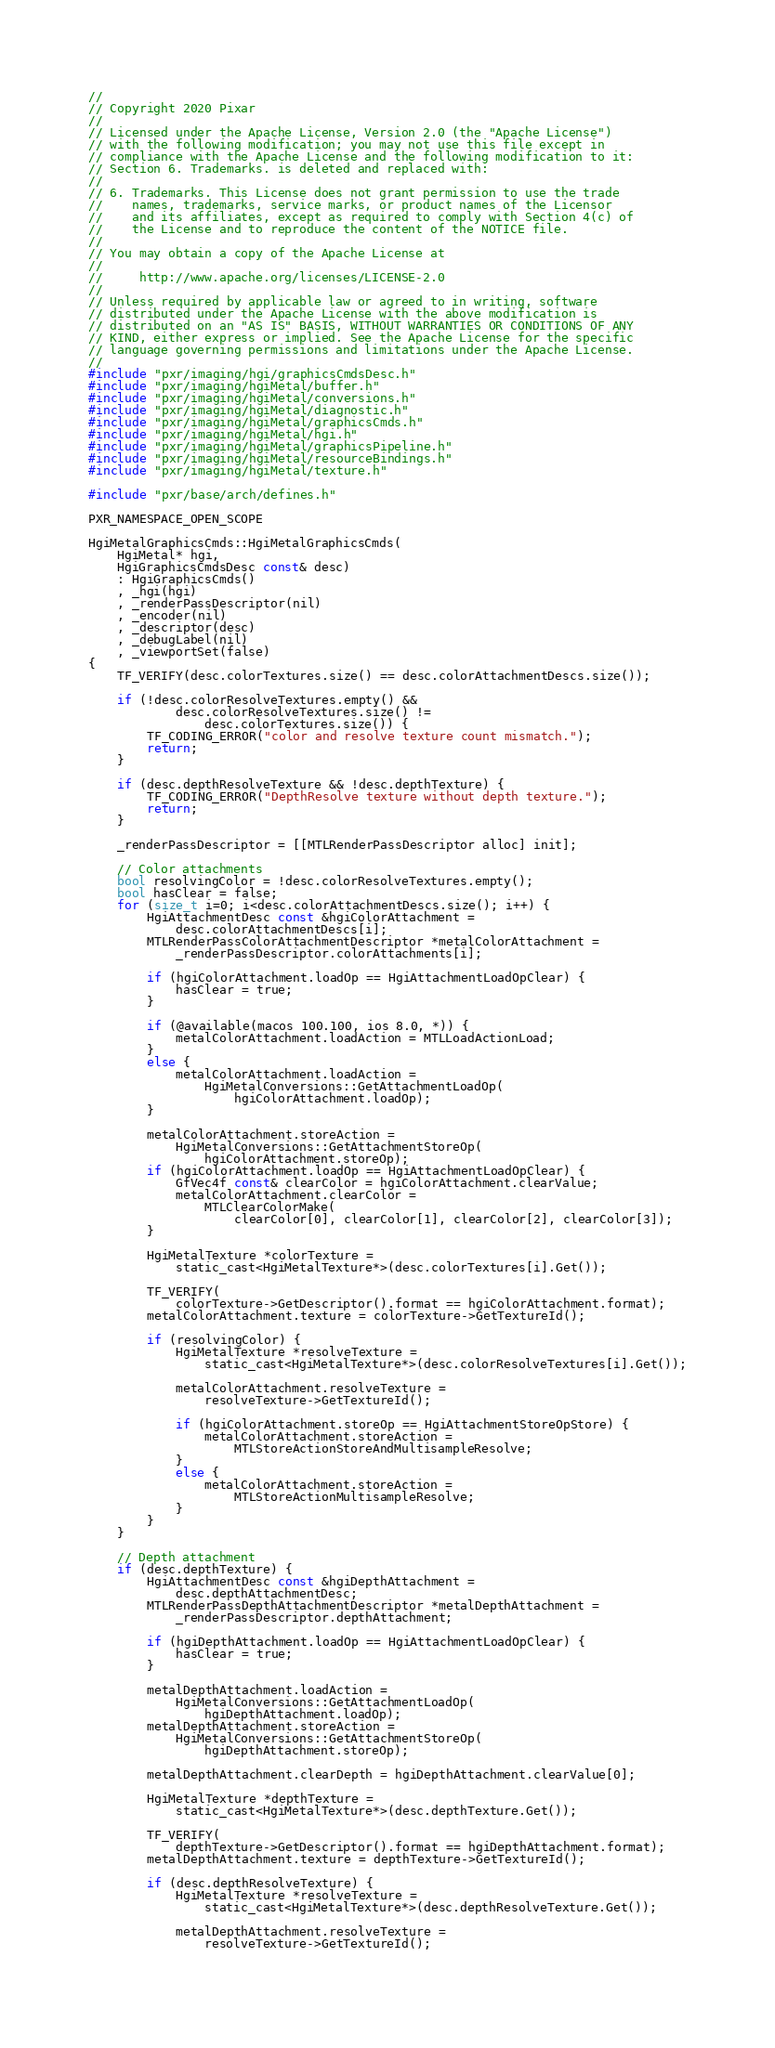Convert code to text. <code><loc_0><loc_0><loc_500><loc_500><_ObjectiveC_>//
// Copyright 2020 Pixar
//
// Licensed under the Apache License, Version 2.0 (the "Apache License")
// with the following modification; you may not use this file except in
// compliance with the Apache License and the following modification to it:
// Section 6. Trademarks. is deleted and replaced with:
//
// 6. Trademarks. This License does not grant permission to use the trade
//    names, trademarks, service marks, or product names of the Licensor
//    and its affiliates, except as required to comply with Section 4(c) of
//    the License and to reproduce the content of the NOTICE file.
//
// You may obtain a copy of the Apache License at
//
//     http://www.apache.org/licenses/LICENSE-2.0
//
// Unless required by applicable law or agreed to in writing, software
// distributed under the Apache License with the above modification is
// distributed on an "AS IS" BASIS, WITHOUT WARRANTIES OR CONDITIONS OF ANY
// KIND, either express or implied. See the Apache License for the specific
// language governing permissions and limitations under the Apache License.
//
#include "pxr/imaging/hgi/graphicsCmdsDesc.h"
#include "pxr/imaging/hgiMetal/buffer.h"
#include "pxr/imaging/hgiMetal/conversions.h"
#include "pxr/imaging/hgiMetal/diagnostic.h"
#include "pxr/imaging/hgiMetal/graphicsCmds.h"
#include "pxr/imaging/hgiMetal/hgi.h"
#include "pxr/imaging/hgiMetal/graphicsPipeline.h"
#include "pxr/imaging/hgiMetal/resourceBindings.h"
#include "pxr/imaging/hgiMetal/texture.h"

#include "pxr/base/arch/defines.h"

PXR_NAMESPACE_OPEN_SCOPE

HgiMetalGraphicsCmds::HgiMetalGraphicsCmds(
    HgiMetal* hgi,
    HgiGraphicsCmdsDesc const& desc)
    : HgiGraphicsCmds()
    , _hgi(hgi)
    , _renderPassDescriptor(nil)
    , _encoder(nil)
    , _descriptor(desc)
    , _debugLabel(nil)
    , _viewportSet(false)
{
    TF_VERIFY(desc.colorTextures.size() == desc.colorAttachmentDescs.size());
    
    if (!desc.colorResolveTextures.empty() &&
            desc.colorResolveTextures.size() !=
                desc.colorTextures.size()) {
        TF_CODING_ERROR("color and resolve texture count mismatch.");
        return;
    }

    if (desc.depthResolveTexture && !desc.depthTexture) {
        TF_CODING_ERROR("DepthResolve texture without depth texture.");
        return;
    }

    _renderPassDescriptor = [[MTLRenderPassDescriptor alloc] init];

    // Color attachments
    bool resolvingColor = !desc.colorResolveTextures.empty();
    bool hasClear = false;
    for (size_t i=0; i<desc.colorAttachmentDescs.size(); i++) {
        HgiAttachmentDesc const &hgiColorAttachment =
            desc.colorAttachmentDescs[i];
        MTLRenderPassColorAttachmentDescriptor *metalColorAttachment =
            _renderPassDescriptor.colorAttachments[i];

        if (hgiColorAttachment.loadOp == HgiAttachmentLoadOpClear) {
            hasClear = true;
        }
        
        if (@available(macos 100.100, ios 8.0, *)) {
            metalColorAttachment.loadAction = MTLLoadActionLoad;
        }
        else {
            metalColorAttachment.loadAction =
                HgiMetalConversions::GetAttachmentLoadOp(
                    hgiColorAttachment.loadOp);
        }

        metalColorAttachment.storeAction =
            HgiMetalConversions::GetAttachmentStoreOp(
                hgiColorAttachment.storeOp);
        if (hgiColorAttachment.loadOp == HgiAttachmentLoadOpClear) {
            GfVec4f const& clearColor = hgiColorAttachment.clearValue;
            metalColorAttachment.clearColor =
                MTLClearColorMake(
                    clearColor[0], clearColor[1], clearColor[2], clearColor[3]);
        }
        
        HgiMetalTexture *colorTexture =
            static_cast<HgiMetalTexture*>(desc.colorTextures[i].Get());

        TF_VERIFY(
            colorTexture->GetDescriptor().format == hgiColorAttachment.format);
        metalColorAttachment.texture = colorTexture->GetTextureId();
        
        if (resolvingColor) {
            HgiMetalTexture *resolveTexture =
                static_cast<HgiMetalTexture*>(desc.colorResolveTextures[i].Get());

            metalColorAttachment.resolveTexture =
                resolveTexture->GetTextureId();

            if (hgiColorAttachment.storeOp == HgiAttachmentStoreOpStore) {
                metalColorAttachment.storeAction =
                    MTLStoreActionStoreAndMultisampleResolve;
            }
            else {
                metalColorAttachment.storeAction =
                    MTLStoreActionMultisampleResolve;
            }
        }
    }

    // Depth attachment
    if (desc.depthTexture) {
        HgiAttachmentDesc const &hgiDepthAttachment =
            desc.depthAttachmentDesc;
        MTLRenderPassDepthAttachmentDescriptor *metalDepthAttachment =
            _renderPassDescriptor.depthAttachment;

        if (hgiDepthAttachment.loadOp == HgiAttachmentLoadOpClear) {
            hasClear = true;
        }

        metalDepthAttachment.loadAction =
            HgiMetalConversions::GetAttachmentLoadOp(
                hgiDepthAttachment.loadOp);
        metalDepthAttachment.storeAction =
            HgiMetalConversions::GetAttachmentStoreOp(
                hgiDepthAttachment.storeOp);
        
        metalDepthAttachment.clearDepth = hgiDepthAttachment.clearValue[0];
        
        HgiMetalTexture *depthTexture =
            static_cast<HgiMetalTexture*>(desc.depthTexture.Get());
        
        TF_VERIFY(
            depthTexture->GetDescriptor().format == hgiDepthAttachment.format);
        metalDepthAttachment.texture = depthTexture->GetTextureId();
        
        if (desc.depthResolveTexture) {
            HgiMetalTexture *resolveTexture =
                static_cast<HgiMetalTexture*>(desc.depthResolveTexture.Get());

            metalDepthAttachment.resolveTexture =
                resolveTexture->GetTextureId();
            </code> 